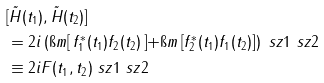<formula> <loc_0><loc_0><loc_500><loc_500>& [ \tilde { H } ( t _ { 1 } ) , \tilde { H } ( t _ { 2 } ) ] \\ & = 2 i \left ( \i m \right [ f _ { 1 } ^ { * } ( t _ { 1 } ) f _ { 2 } ( t _ { 2 } ) \left ] + \i m \left [ f _ { 2 } ^ { * } ( t _ { 1 } ) f _ { 1 } ( t _ { 2 } ) \right ] \right ) \ s z { 1 } \ s z { 2 } \\ & \equiv 2 i F ( t _ { 1 } , t _ { 2 } ) \ s z { 1 } \ s z { 2 }</formula> 